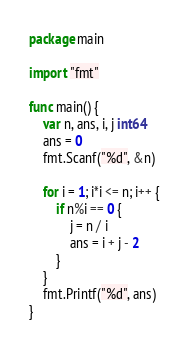Convert code to text. <code><loc_0><loc_0><loc_500><loc_500><_Go_>package main

import "fmt"

func main() {
	var n, ans, i, j int64
	ans = 0
	fmt.Scanf("%d", &n)

	for i = 1; i*i <= n; i++ {
		if n%i == 0 {
			j = n / i
			ans = i + j - 2
		}
	}
	fmt.Printf("%d", ans)
}
</code> 